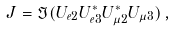<formula> <loc_0><loc_0><loc_500><loc_500>J = \Im ( U _ { e 2 } U _ { e 3 } ^ { * } U _ { \mu 2 } ^ { * } U _ { \mu 3 } ) \, ,</formula> 